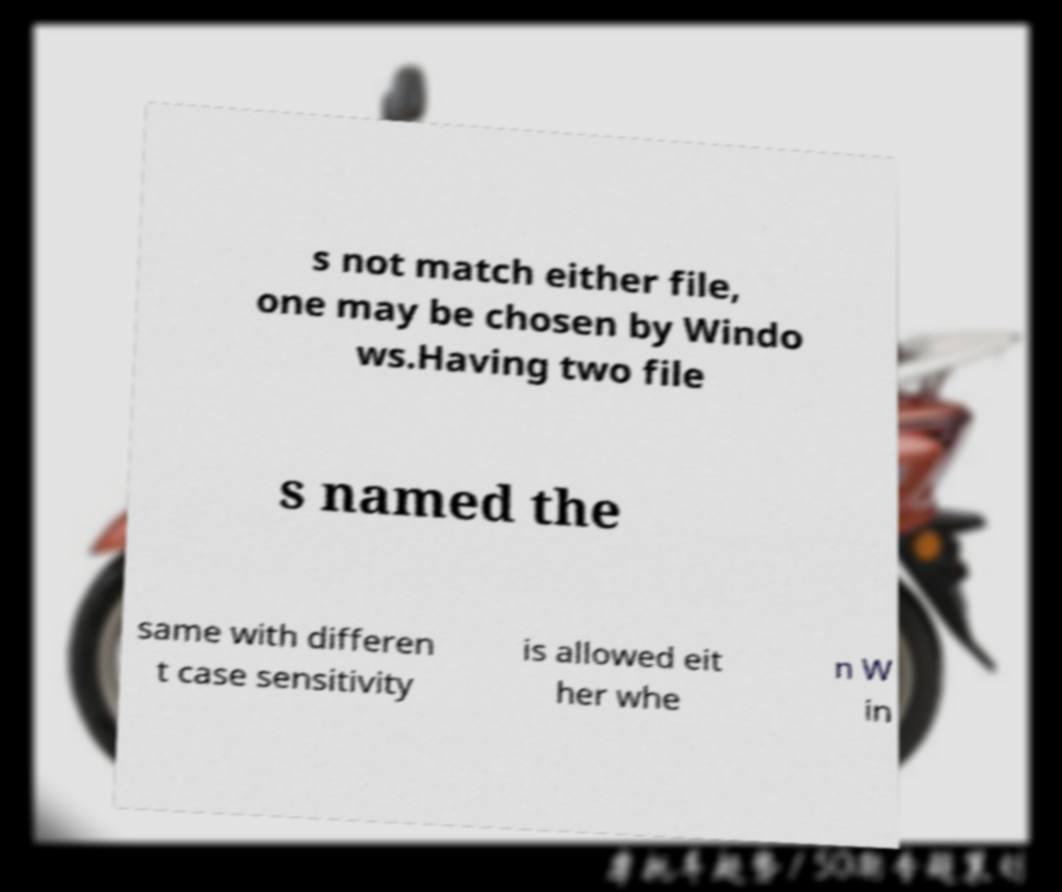What messages or text are displayed in this image? I need them in a readable, typed format. s not match either file, one may be chosen by Windo ws.Having two file s named the same with differen t case sensitivity is allowed eit her whe n W in 